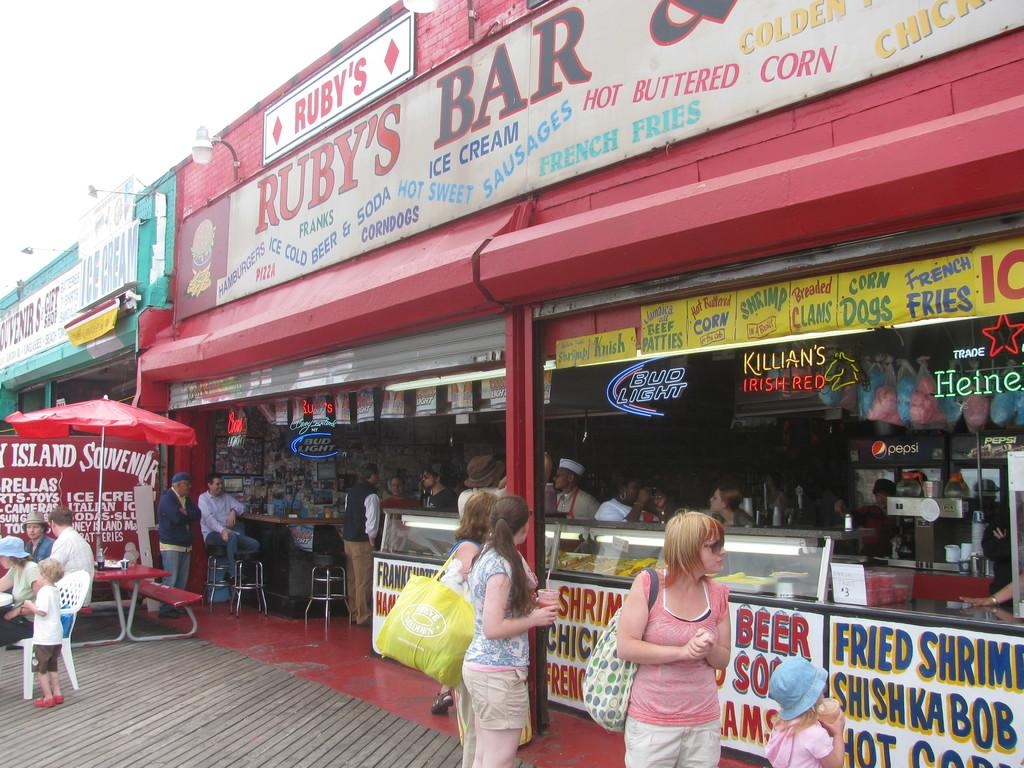<image>
Share a concise interpretation of the image provided. Many people sit inside of Ruby's Bar on the boardwalk. 